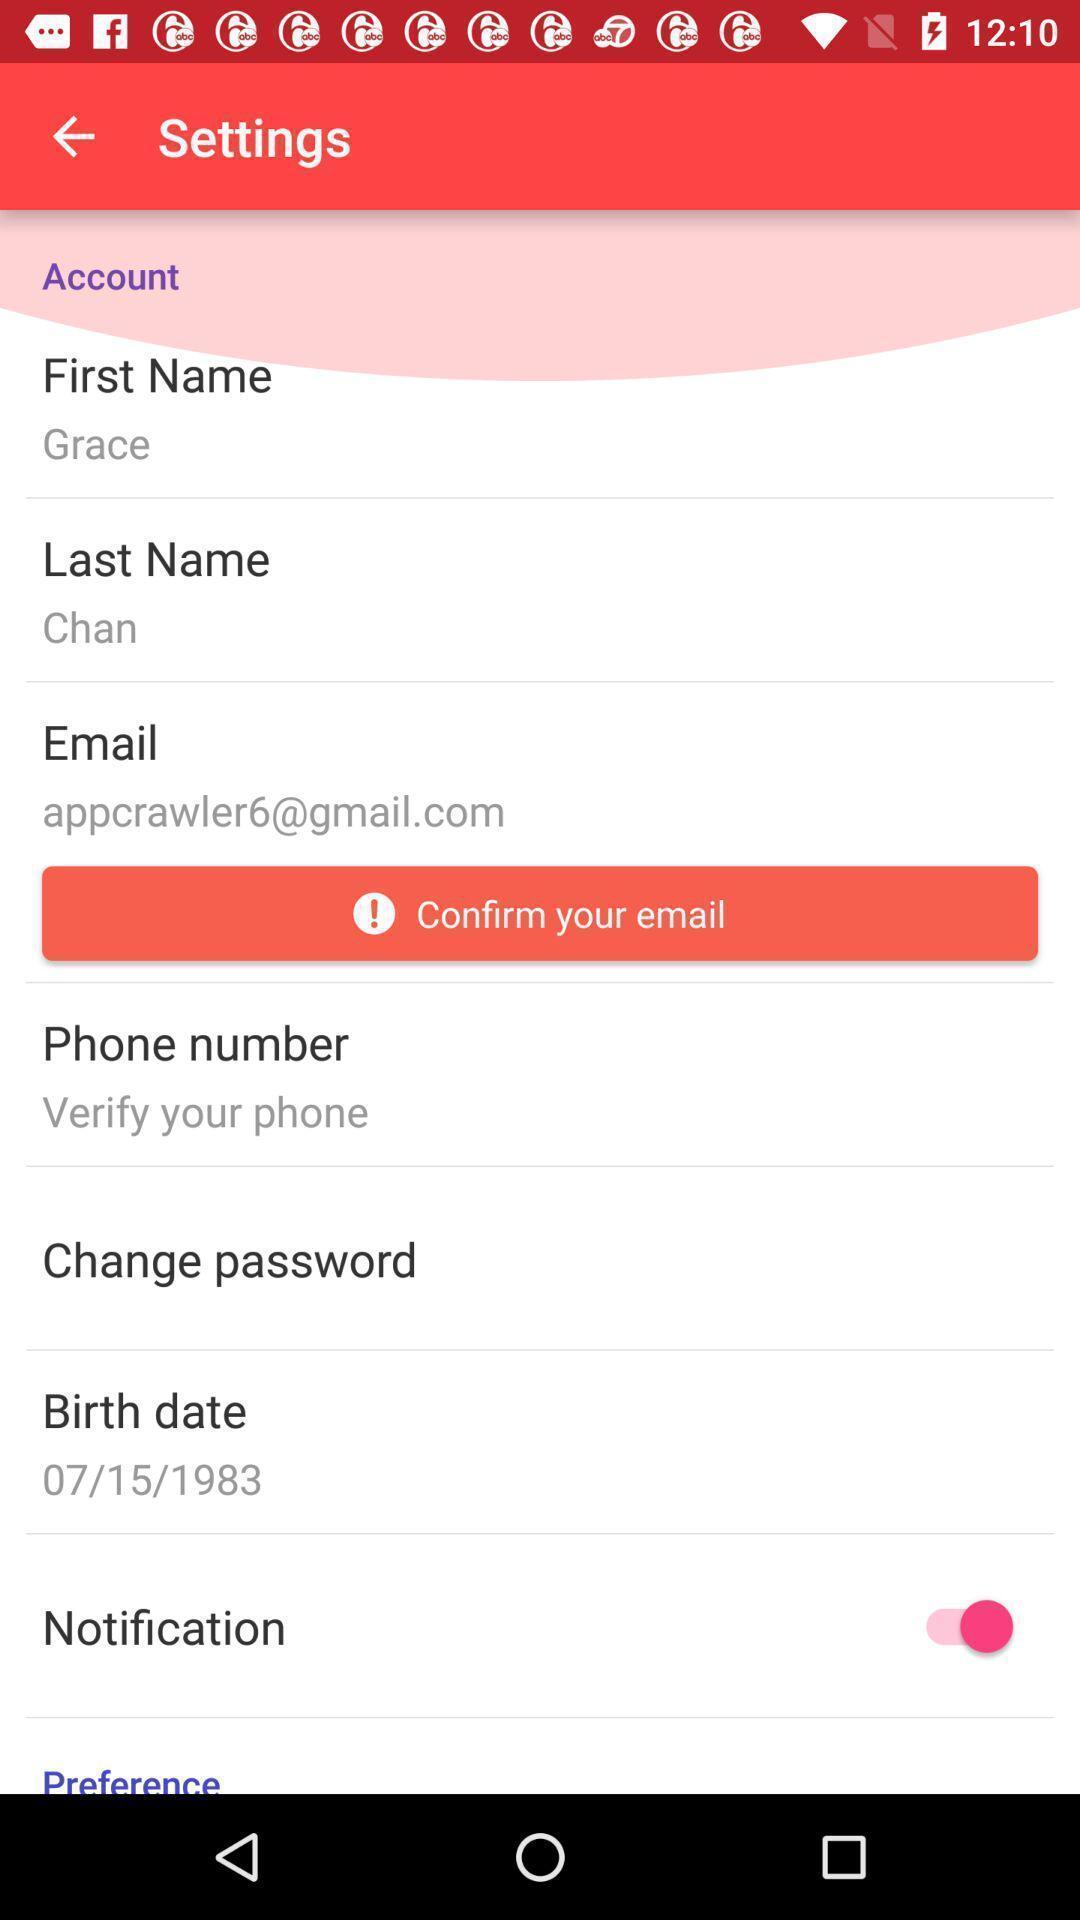Give me a narrative description of this picture. Various settings available in the application. 